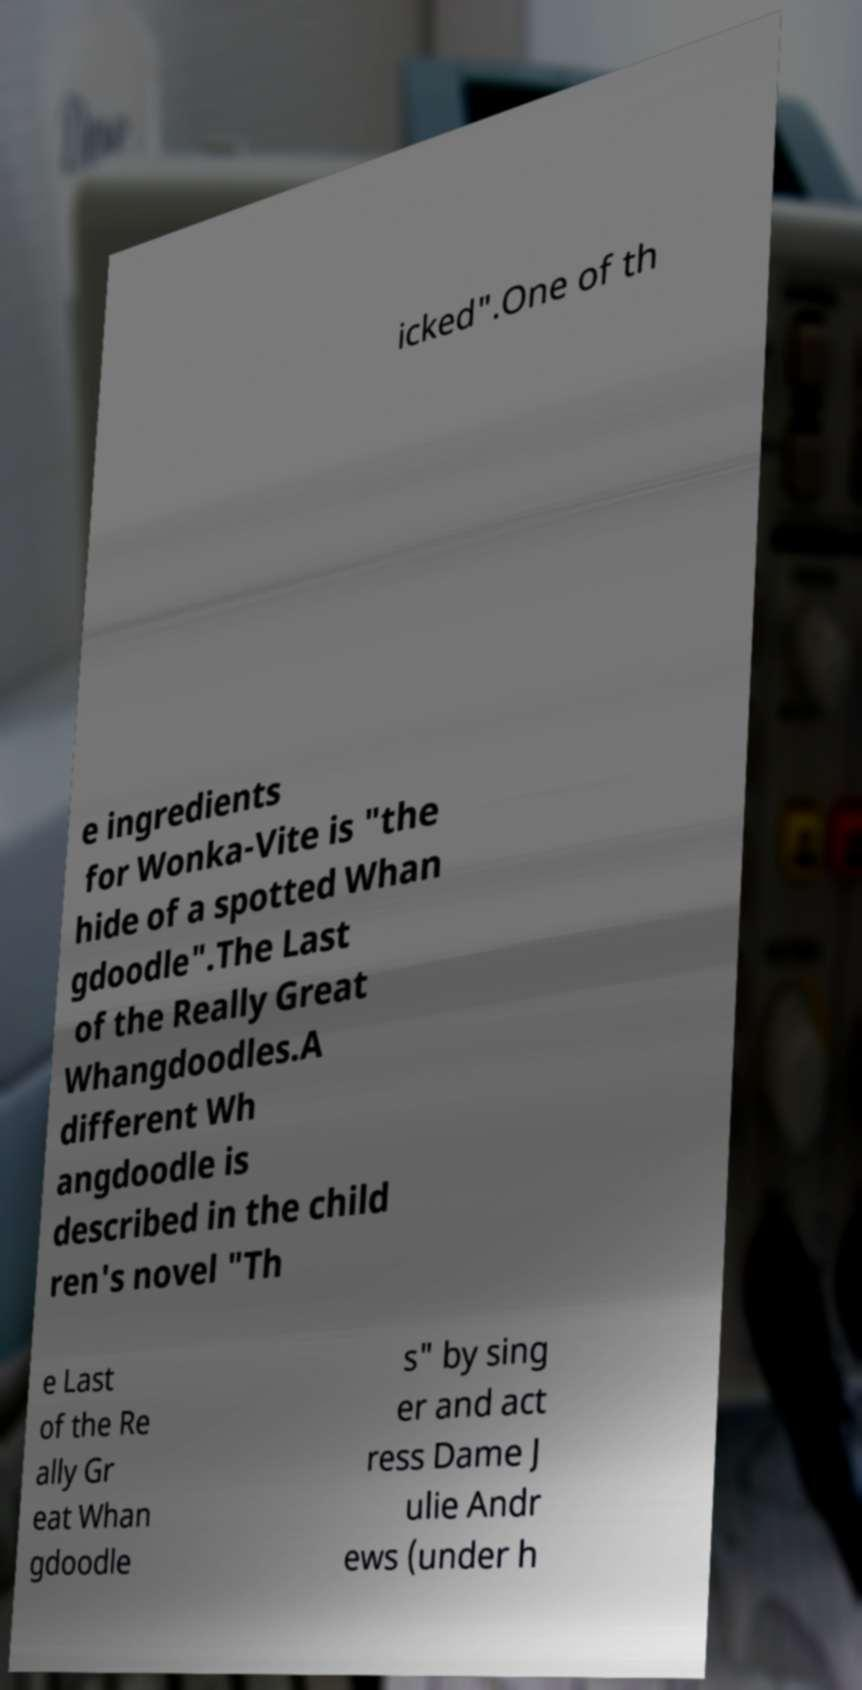What messages or text are displayed in this image? I need them in a readable, typed format. icked".One of th e ingredients for Wonka-Vite is "the hide of a spotted Whan gdoodle".The Last of the Really Great Whangdoodles.A different Wh angdoodle is described in the child ren's novel "Th e Last of the Re ally Gr eat Whan gdoodle s" by sing er and act ress Dame J ulie Andr ews (under h 